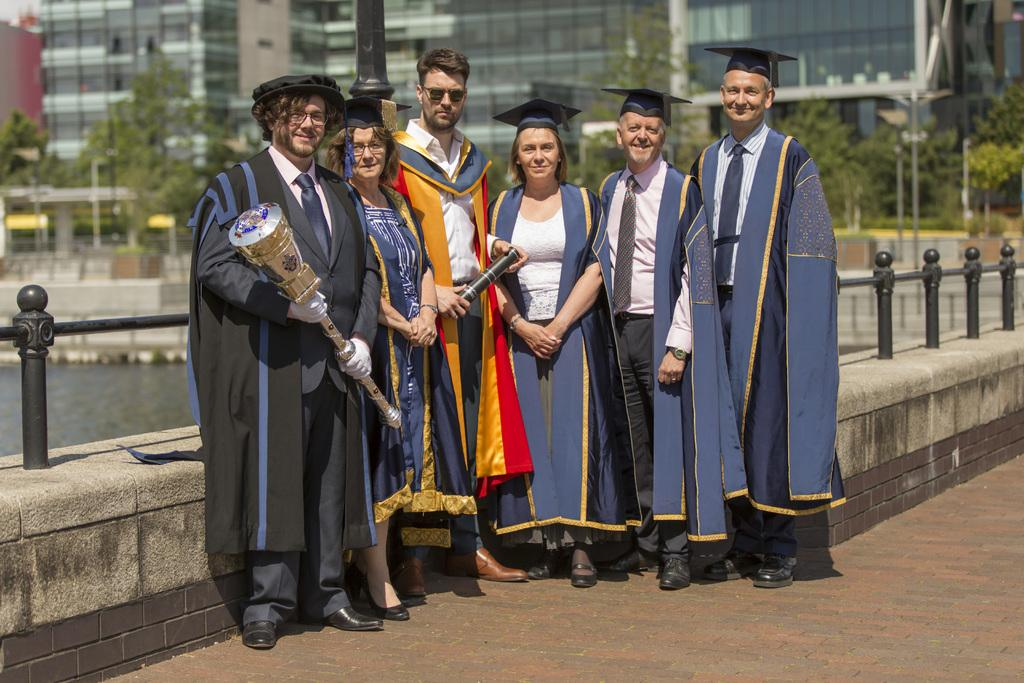What are the persons in the image wearing? The persons in the image are wearing costumes. What can be seen in the background of the image? There is an iron fence, trees, and buildings in the background. How many quinces are present in the image? There are no quinces present in the image. What is the measurement of the iron fence in the image? The measurement of the iron fence cannot be determined from the image. 